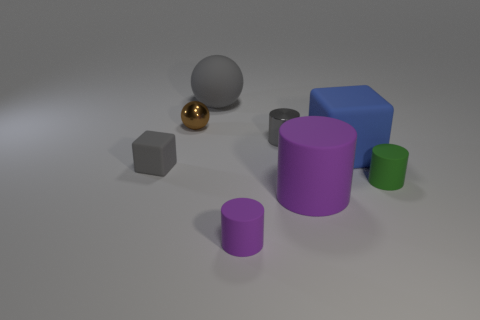Subtract 1 cylinders. How many cylinders are left? 3 Add 1 purple metallic spheres. How many objects exist? 9 Subtract all blocks. How many objects are left? 6 Add 3 large purple matte cylinders. How many large purple matte cylinders exist? 4 Subtract 0 yellow balls. How many objects are left? 8 Subtract all big purple objects. Subtract all gray rubber objects. How many objects are left? 5 Add 5 big blue rubber objects. How many big blue rubber objects are left? 6 